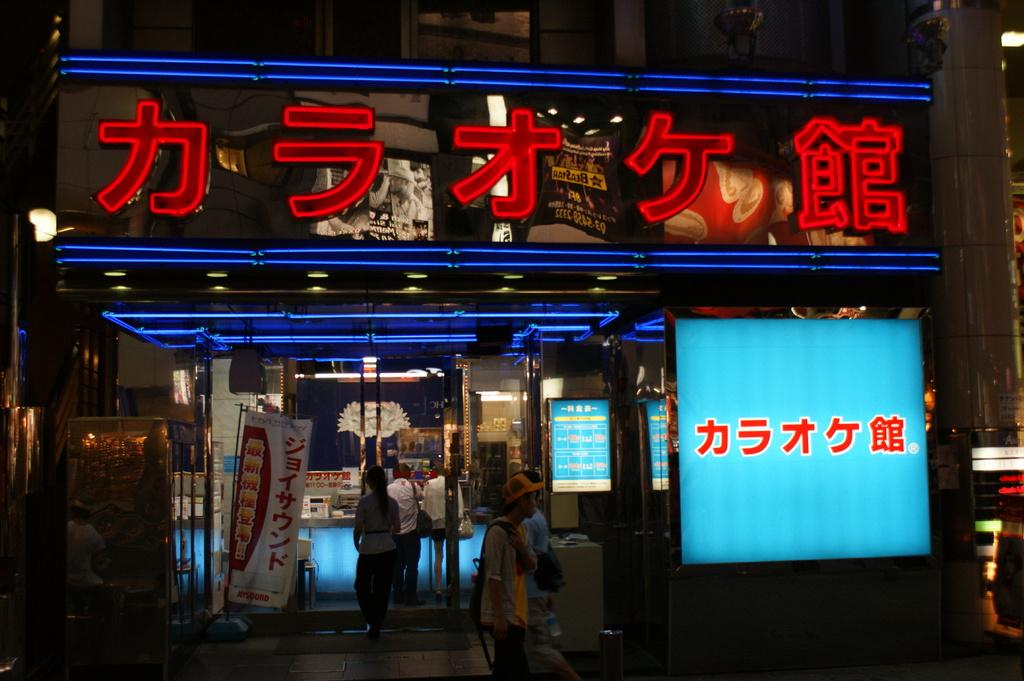Who or what can be seen in the image? There are people in the image. What objects are present in the image that might be used for displaying information or entertainment? There are screens and banners in the image. What type of structure is visible in the image? There is a wall and a building in the image. How would you describe the lighting conditions in the image? The image is slightly dark, but there is a light on the left side of the image. What type of club can be seen in the image? There is no club present in the image. 